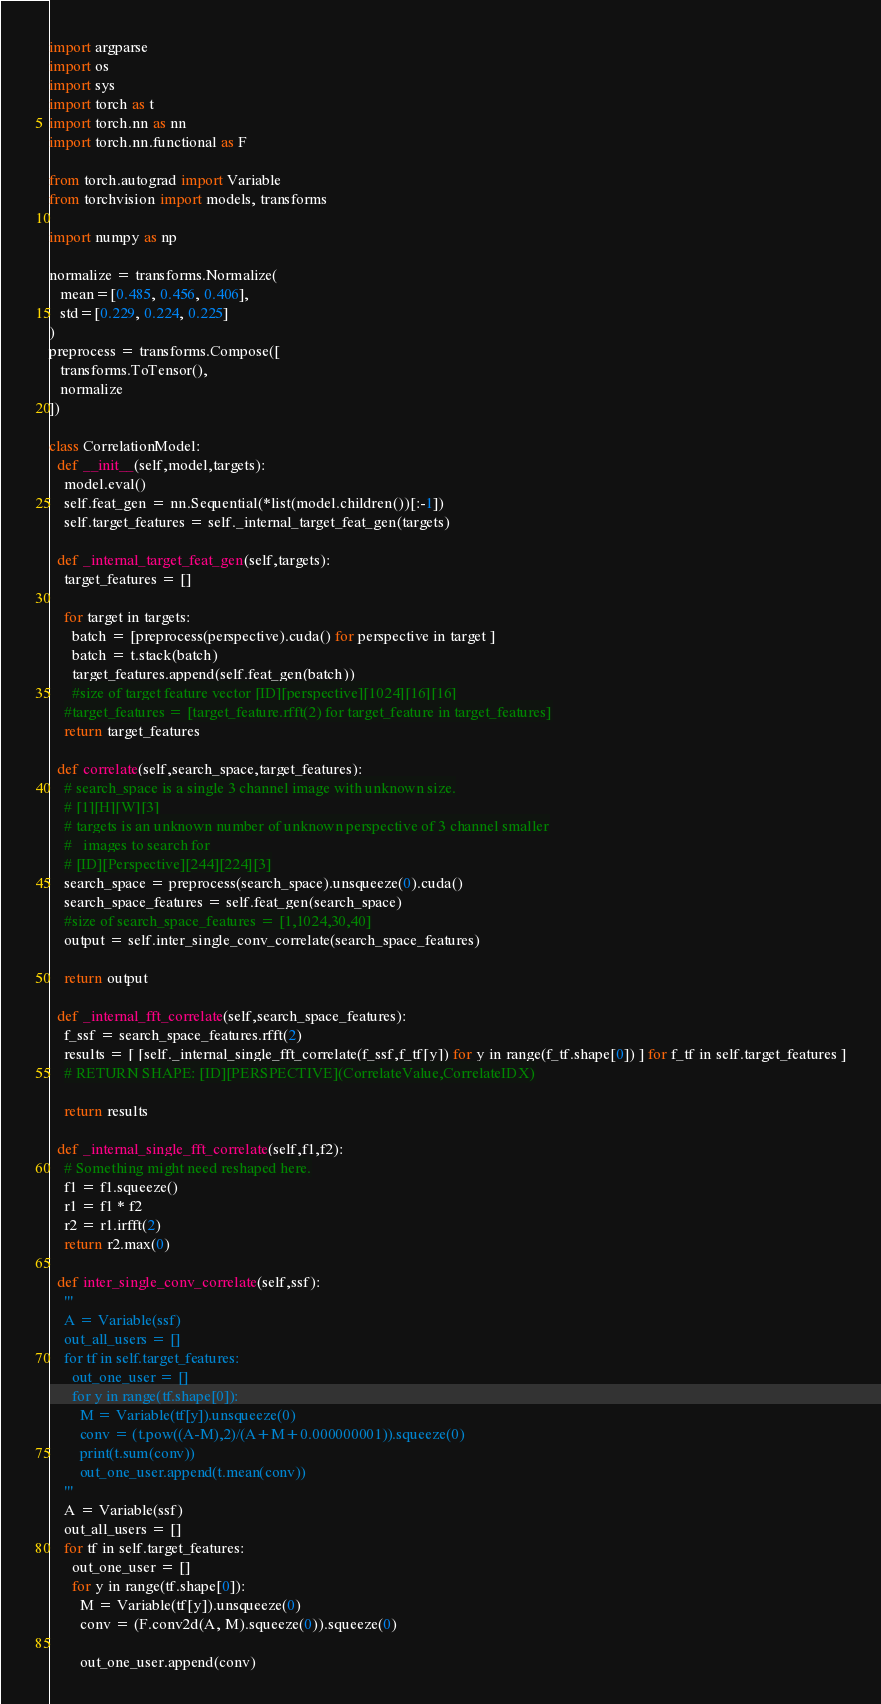<code> <loc_0><loc_0><loc_500><loc_500><_Python_>
import argparse
import os
import sys
import torch as t
import torch.nn as nn
import torch.nn.functional as F

from torch.autograd import Variable
from torchvision import models, transforms

import numpy as np

normalize = transforms.Normalize(
   mean=[0.485, 0.456, 0.406],
   std=[0.229, 0.224, 0.225]
)
preprocess = transforms.Compose([
   transforms.ToTensor(),
   normalize
])

class CorrelationModel:
  def __init__(self,model,targets):
    model.eval()
    self.feat_gen = nn.Sequential(*list(model.children())[:-1])
    self.target_features = self._internal_target_feat_gen(targets)

  def _internal_target_feat_gen(self,targets):
    target_features = []

    for target in targets:
      batch = [preprocess(perspective).cuda() for perspective in target ]
      batch = t.stack(batch)
      target_features.append(self.feat_gen(batch))
      #size of target feature vector [ID][perspective][1024][16][16]
    #target_features = [target_feature.rfft(2) for target_feature in target_features]
    return target_features

  def correlate(self,search_space,target_features):
    # search_space is a single 3 channel image with unknown size.
    # [1][H][W][3]
    # targets is an unknown number of unknown perspective of 3 channel smaller
    #   images to search for
    # [ID][Perspective][244][224][3]
    search_space = preprocess(search_space).unsqueeze(0).cuda()
    search_space_features = self.feat_gen(search_space)
    #size of search_space_features = [1,1024,30,40]
    output = self.inter_single_conv_correlate(search_space_features)

    return output

  def _internal_fft_correlate(self,search_space_features):
    f_ssf = search_space_features.rfft(2)
    results = [ [self._internal_single_fft_correlate(f_ssf,f_tf[y]) for y in range(f_tf.shape[0]) ] for f_tf in self.target_features ]
    # RETURN SHAPE: [ID][PERSPECTIVE](CorrelateValue,CorrelateIDX)

    return results

  def _internal_single_fft_correlate(self,f1,f2):
    # Something might need reshaped here.
    f1 = f1.squeeze()
    r1 = f1 * f2
    r2 = r1.irfft(2)
    return r2.max(0)

  def inter_single_conv_correlate(self,ssf):
    '''
    A = Variable(ssf)
    out_all_users = []
    for tf in self.target_features:
      out_one_user = []
      for y in range(tf.shape[0]):
        M = Variable(tf[y]).unsqueeze(0)
        conv = (t.pow((A-M),2)/(A+M+0.000000001)).squeeze(0)
        print(t.sum(conv))
        out_one_user.append(t.mean(conv))
    '''
    A = Variable(ssf)
    out_all_users = []
    for tf in self.target_features:
      out_one_user = []
      for y in range(tf.shape[0]):
        M = Variable(tf[y]).unsqueeze(0)
        conv = (F.conv2d(A, M).squeeze(0)).squeeze(0)

        out_one_user.append(conv)
</code> 